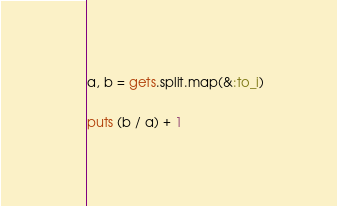<code> <loc_0><loc_0><loc_500><loc_500><_Ruby_>a, b = gets.split.map(&:to_i)

puts (b / a) + 1</code> 